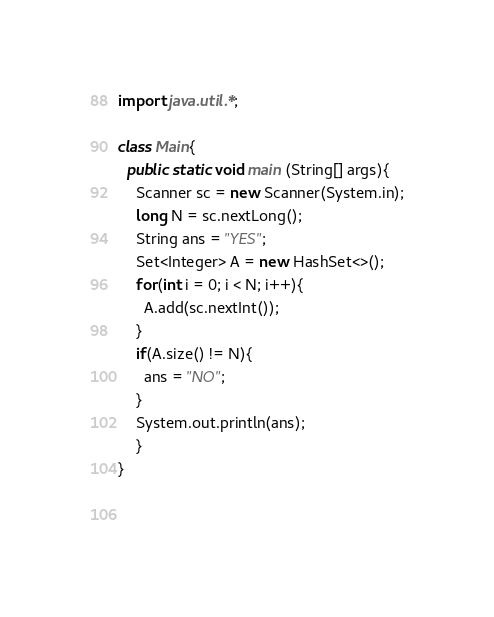Convert code to text. <code><loc_0><loc_0><loc_500><loc_500><_Java_>import java.util.*;
 
class Main{
  public static void main (String[] args){
    Scanner sc = new Scanner(System.in);
    long N = sc.nextLong();
    String ans = "YES";
    Set<Integer> A = new HashSet<>();
    for(int i = 0; i < N; i++){
      A.add(sc.nextInt());
    }
    if(A.size() != N){
      ans = "NO";
    }    
    System.out.println(ans);
    }
}
    
    </code> 